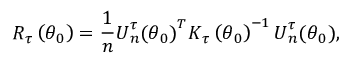<formula> <loc_0><loc_0><loc_500><loc_500>R _ { \tau } \left ( \theta _ { 0 } \right ) = \frac { 1 } { n } U _ { n } ^ { \tau } ( \theta _ { 0 } ) ^ { T } K _ { \tau } \left ( \theta _ { 0 } \right ) ^ { - 1 } U _ { n } ^ { \tau } ( \theta _ { 0 } ) ,</formula> 